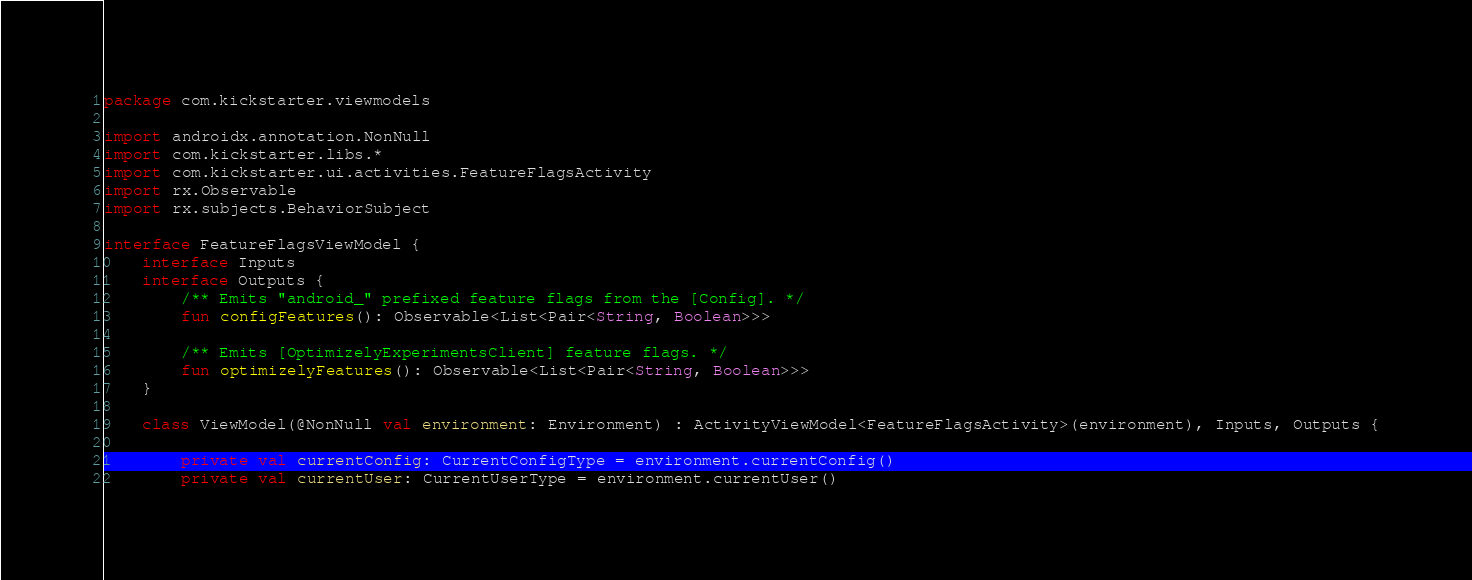<code> <loc_0><loc_0><loc_500><loc_500><_Kotlin_>package com.kickstarter.viewmodels

import androidx.annotation.NonNull
import com.kickstarter.libs.*
import com.kickstarter.ui.activities.FeatureFlagsActivity
import rx.Observable
import rx.subjects.BehaviorSubject

interface FeatureFlagsViewModel {
    interface Inputs
    interface Outputs {
        /** Emits "android_" prefixed feature flags from the [Config]. */
        fun configFeatures(): Observable<List<Pair<String, Boolean>>>

        /** Emits [OptimizelyExperimentsClient] feature flags. */
        fun optimizelyFeatures(): Observable<List<Pair<String, Boolean>>>
    }

    class ViewModel(@NonNull val environment: Environment) : ActivityViewModel<FeatureFlagsActivity>(environment), Inputs, Outputs {

        private val currentConfig: CurrentConfigType = environment.currentConfig()
        private val currentUser: CurrentUserType = environment.currentUser()</code> 